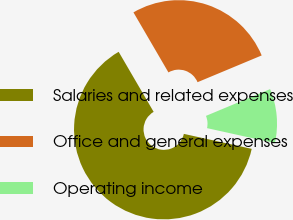Convert chart. <chart><loc_0><loc_0><loc_500><loc_500><pie_chart><fcel>Salaries and related expenses<fcel>Office and general expenses<fcel>Operating income<nl><fcel>63.14%<fcel>27.11%<fcel>9.75%<nl></chart> 